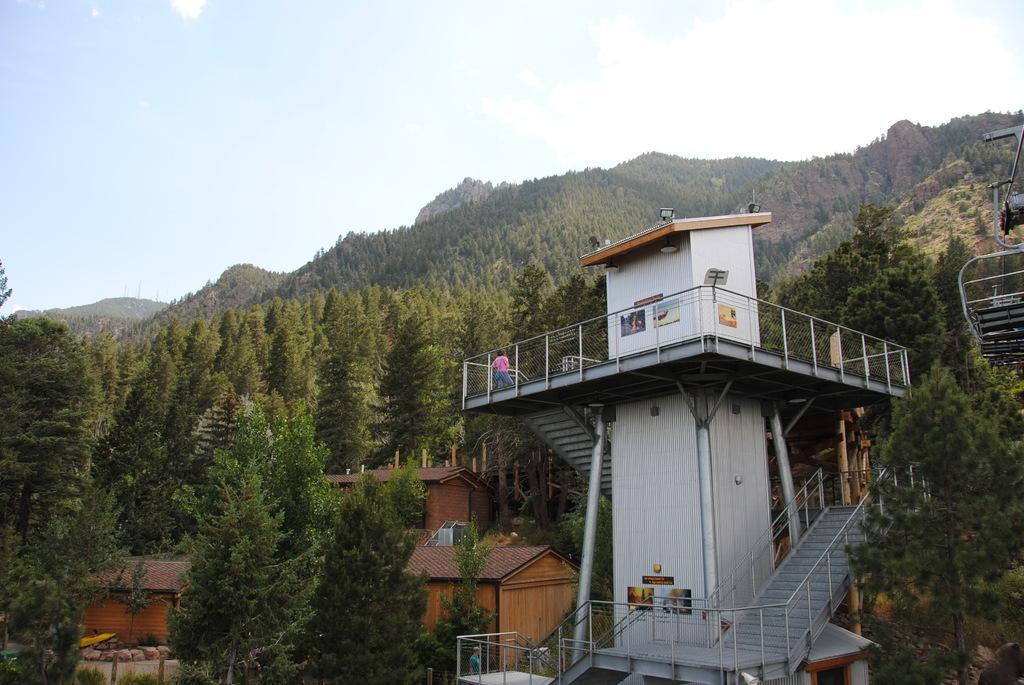Can you describe this image briefly? In the picture I can see buildings, trees, a person is standing on the tower and some other objects. In the background I can see the sky and hills. 